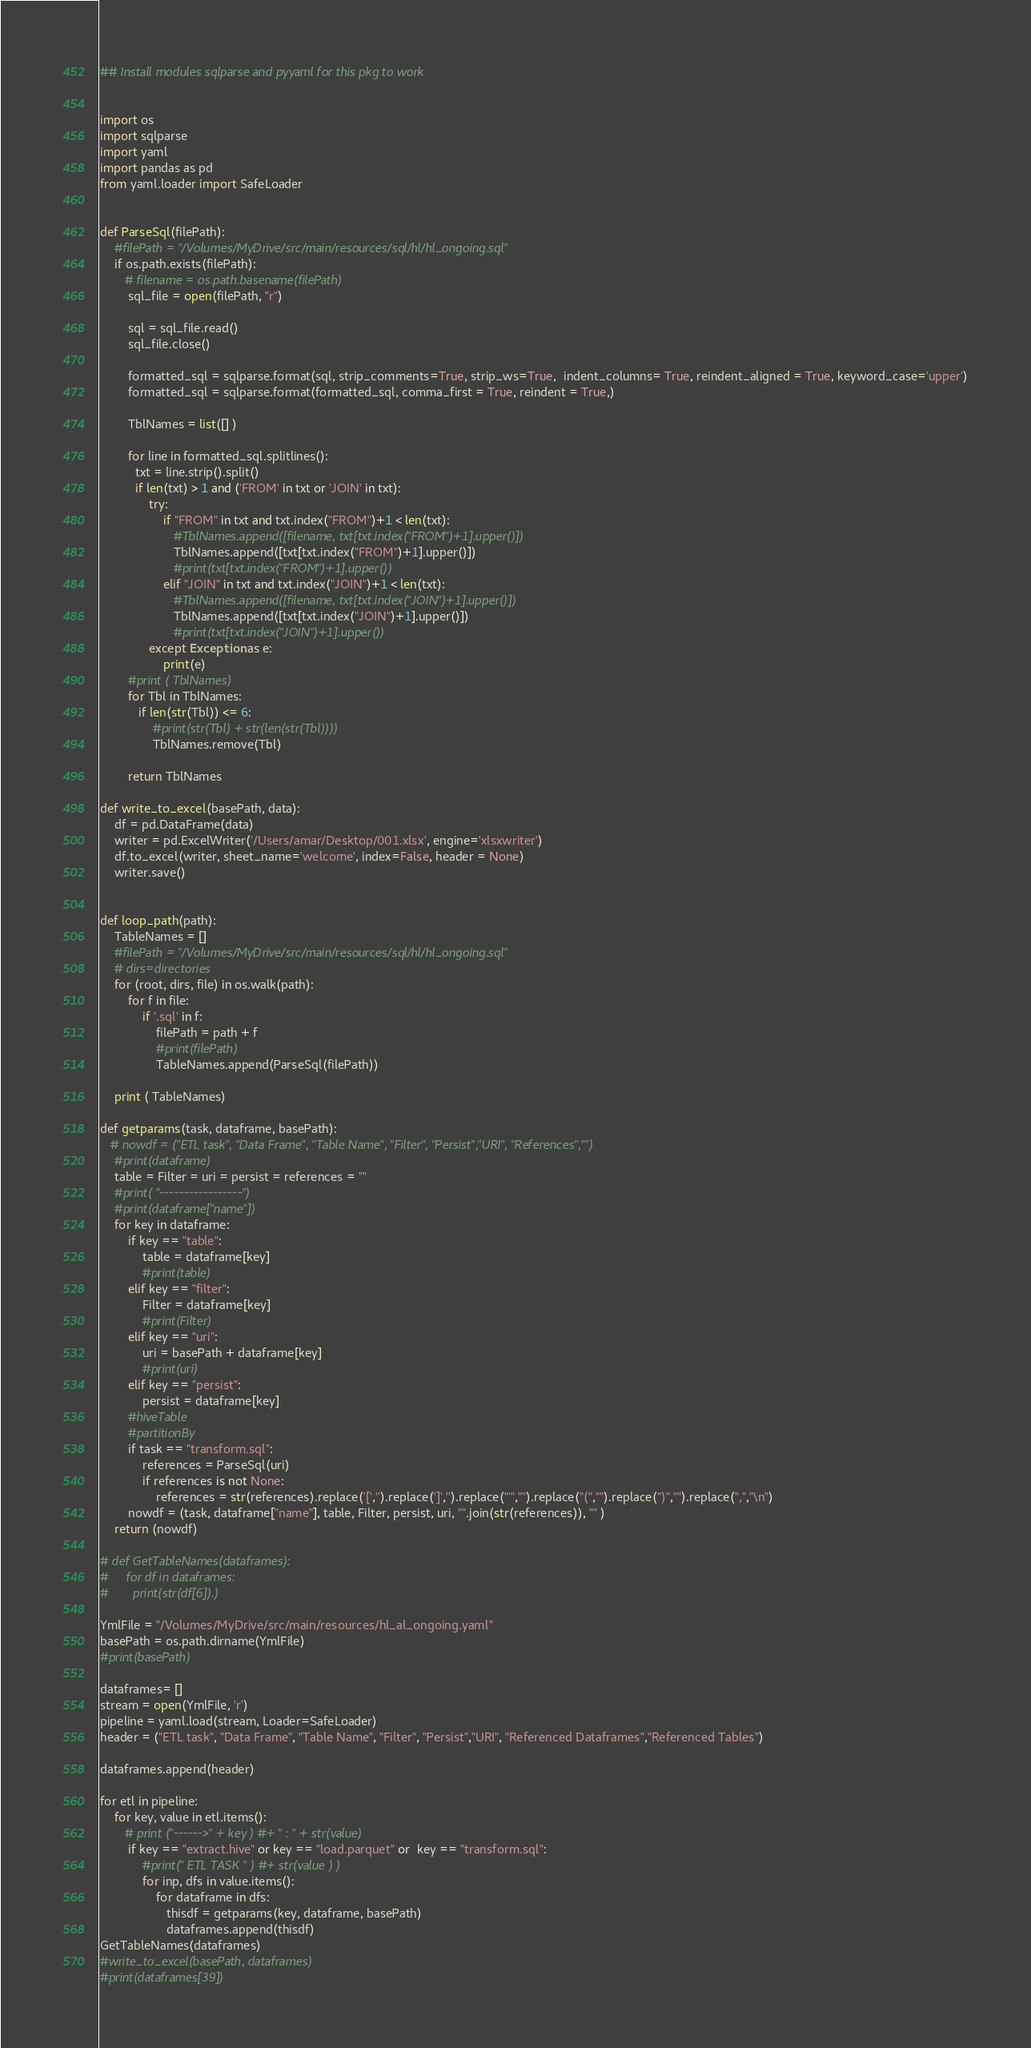Convert code to text. <code><loc_0><loc_0><loc_500><loc_500><_Python_>## Install modules sqlparse and pyyaml for this pkg to work 


import os
import sqlparse
import yaml
import pandas as pd
from yaml.loader import SafeLoader


def ParseSql(filePath):
    #filePath = "/Volumes/MyDrive/src/main/resources/sql/hl/hl_ongoing.sql"
    if os.path.exists(filePath):    
       # filename = os.path.basename(filePath)
        sql_file = open(filePath, "r")
        
        sql = sql_file.read()
        sql_file.close()
        
        formatted_sql = sqlparse.format(sql, strip_comments=True, strip_ws=True,  indent_columns= True, reindent_aligned = True, keyword_case='upper')
        formatted_sql = sqlparse.format(formatted_sql, comma_first = True, reindent = True,)
        
        TblNames = list([] )
        
        for line in formatted_sql.splitlines():
          txt = line.strip().split()
          if len(txt) > 1 and ('FROM' in txt or 'JOIN' in txt):
              try:
                  if "FROM" in txt and txt.index("FROM")+1 < len(txt):
                     #TblNames.append([filename, txt[txt.index("FROM")+1].upper()])
                     TblNames.append([txt[txt.index("FROM")+1].upper()])
                     #print(txt[txt.index("FROM")+1].upper())
                  elif "JOIN" in txt and txt.index("JOIN")+1 < len(txt):
                     #TblNames.append([filename, txt[txt.index("JOIN")+1].upper()])
                     TblNames.append([txt[txt.index("JOIN")+1].upper()])
                     #print(txt[txt.index("JOIN")+1].upper())
              except Exception as e:
                  print(e)
        #print ( TblNames)
        for Tbl in TblNames:
           if len(str(Tbl)) <= 6:
               #print(str(Tbl) + str(len(str(Tbl))))
               TblNames.remove(Tbl)

        return TblNames
              
def write_to_excel(basePath, data):
    df = pd.DataFrame(data)
    writer = pd.ExcelWriter('/Users/amar/Desktop/001.xlsx', engine='xlsxwriter')
    df.to_excel(writer, sheet_name='welcome', index=False, header = None)
    writer.save()
    

def loop_path(path):
    TableNames = []
    #filePath = "/Volumes/MyDrive/src/main/resources/sql/hl/hl_ongoing.sql"
    # dirs=directories
    for (root, dirs, file) in os.walk(path):
        for f in file:
            if '.sql' in f:
                filePath = path + f
                #print(filePath) 
                TableNames.append(ParseSql(filePath))

    print ( TableNames)
    
def getparams(task, dataframe, basePath):
   # nowdf = ("ETL task", "Data Frame", "Table Name", "Filter", "Persist","URI", "References","")
    #print(dataframe)
    table = Filter = uri = persist = references = ""
    #print( "-----------------")
    #print(dataframe["name"])
    for key in dataframe:
        if key == "table":
            table = dataframe[key]
            #print(table)
        elif key == "filter":
            Filter = dataframe[key]
            #print(Filter)
        elif key == "uri":
            uri = basePath + dataframe[key]
            #print(uri)
        elif key == "persist":
            persist = dataframe[key]
        #hiveTable
        #partitionBy
        if task == "transform.sql": 
            references = ParseSql(uri)
            if references is not None:
                references = str(references).replace('[','').replace(']','').replace("'","").replace("(","").replace(")","").replace(",","\n")
        nowdf = (task, dataframe["name"], table, Filter, persist, uri, "".join(str(references)), "" )
    return (nowdf)            

# def GetTableNames(dataframes):
#     for df in dataframes:
#       print(str(df[6]).)
            
YmlFile = "/Volumes/MyDrive/src/main/resources/hl_al_ongoing.yaml"
basePath = os.path.dirname(YmlFile)
#print(basePath)

dataframes= []
stream = open(YmlFile, 'r')
pipeline = yaml.load(stream, Loader=SafeLoader)
header = ("ETL task", "Data Frame", "Table Name", "Filter", "Persist","URI", "Referenced Dataframes","Referenced Tables")

dataframes.append(header)

for etl in pipeline:
    for key, value in etl.items():
       # print ("------>" + key ) #+ " : " + str(value)
        if key == "extract.hive" or key == "load.parquet" or  key == "transform.sql":
            #print(" ETL TASK " ) #+ str(value ) )
            for inp, dfs in value.items():
                for dataframe in dfs: 
                   thisdf = getparams(key, dataframe, basePath)
                   dataframes.append(thisdf)
GetTableNames(dataframes)
#write_to_excel(basePath, dataframes)
#print(dataframes[39])  
</code> 